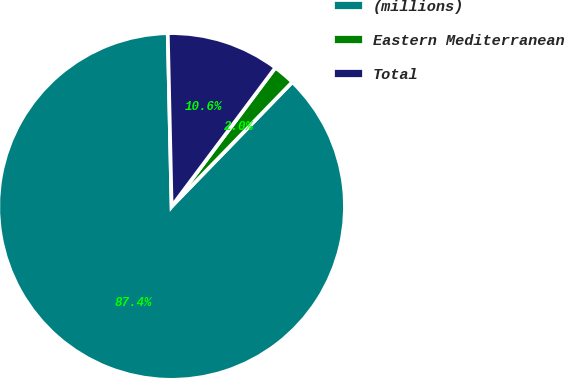<chart> <loc_0><loc_0><loc_500><loc_500><pie_chart><fcel>(millions)<fcel>Eastern Mediterranean<fcel>Total<nl><fcel>87.38%<fcel>2.04%<fcel>10.57%<nl></chart> 